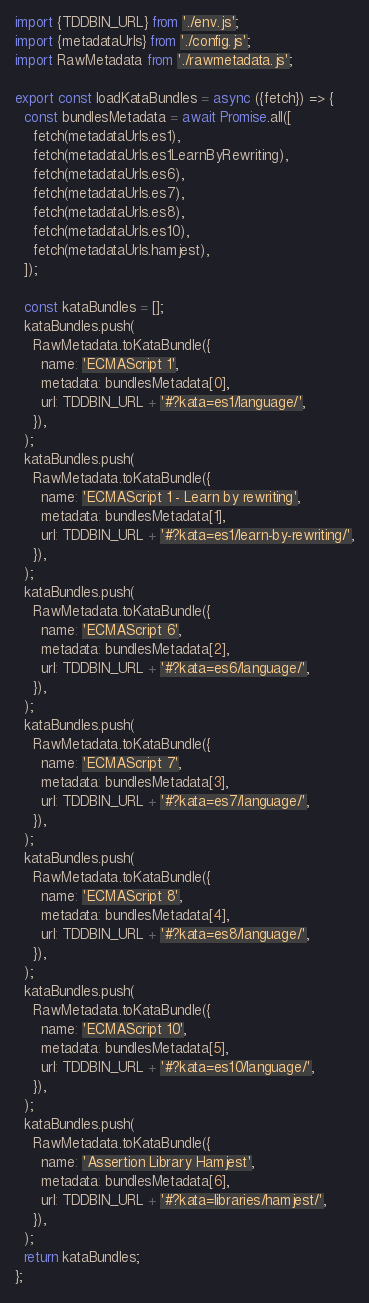<code> <loc_0><loc_0><loc_500><loc_500><_JavaScript_>import {TDDBIN_URL} from './env.js';
import {metadataUrls} from './config.js';
import RawMetadata from './rawmetadata.js';

export const loadKataBundles = async ({fetch}) => {
  const bundlesMetadata = await Promise.all([
    fetch(metadataUrls.es1),
    fetch(metadataUrls.es1LearnByRewriting),
    fetch(metadataUrls.es6),
    fetch(metadataUrls.es7),
    fetch(metadataUrls.es8),
    fetch(metadataUrls.es10),
    fetch(metadataUrls.hamjest),
  ]);

  const kataBundles = [];
  kataBundles.push(
    RawMetadata.toKataBundle({
      name: 'ECMAScript 1',
      metadata: bundlesMetadata[0],
      url: TDDBIN_URL + '#?kata=es1/language/',
    }),
  );
  kataBundles.push(
    RawMetadata.toKataBundle({
      name: 'ECMAScript 1 - Learn by rewriting',
      metadata: bundlesMetadata[1],
      url: TDDBIN_URL + '#?kata=es1/learn-by-rewriting/',
    }),
  );
  kataBundles.push(
    RawMetadata.toKataBundle({
      name: 'ECMAScript 6',
      metadata: bundlesMetadata[2],
      url: TDDBIN_URL + '#?kata=es6/language/',
    }),
  );
  kataBundles.push(
    RawMetadata.toKataBundle({
      name: 'ECMAScript 7',
      metadata: bundlesMetadata[3],
      url: TDDBIN_URL + '#?kata=es7/language/',
    }),
  );
  kataBundles.push(
    RawMetadata.toKataBundle({
      name: 'ECMAScript 8',
      metadata: bundlesMetadata[4],
      url: TDDBIN_URL + '#?kata=es8/language/',
    }),
  );
  kataBundles.push(
    RawMetadata.toKataBundle({
      name: 'ECMAScript 10',
      metadata: bundlesMetadata[5],
      url: TDDBIN_URL + '#?kata=es10/language/',
    }),
  );
  kataBundles.push(
    RawMetadata.toKataBundle({
      name: 'Assertion Library Hamjest',
      metadata: bundlesMetadata[6],
      url: TDDBIN_URL + '#?kata=libraries/hamjest/',
    }),
  );
  return kataBundles;
};
</code> 